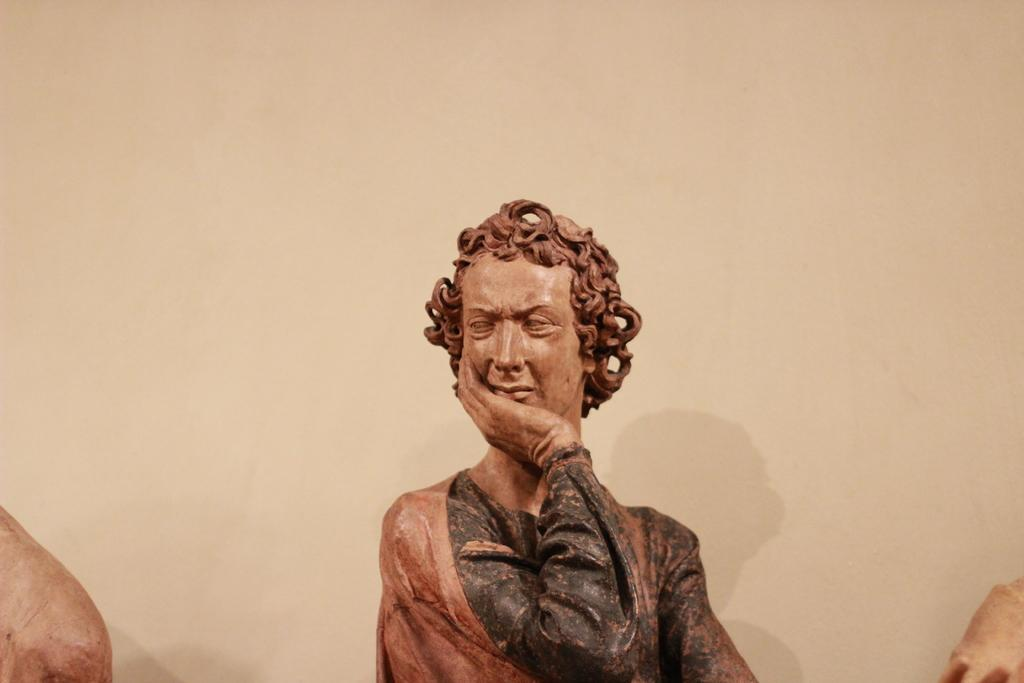What is the main subject of the picture? The main subject of the picture is a statue. What is the statue of? The statue is of a person. Can you describe the person's appearance? The person has curly hair. What is the person in the statue doing with their hand? The person's hand is on their cheek. What type of cloud can be seen in the background of the image? There is no cloud visible in the image, as it features a statue of a person with curly hair and their hand on their cheek. Is there a gold band around the person's finger in the image? There is no mention of a gold band or any jewelry on the person in the image. 